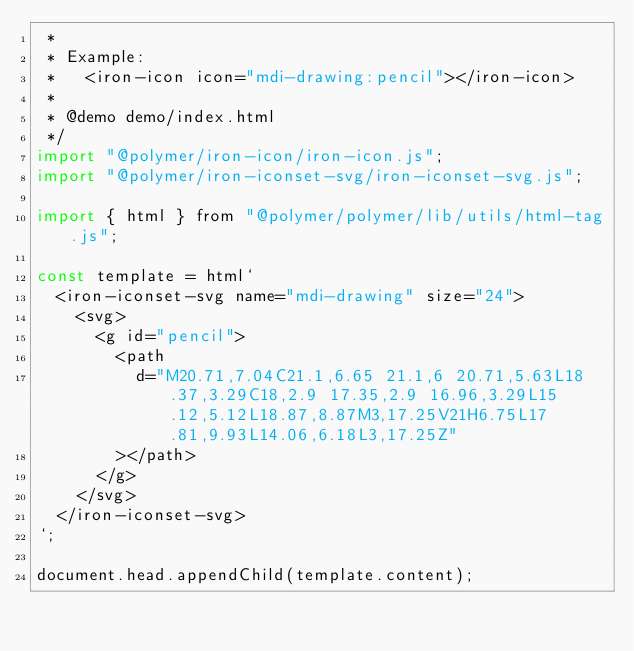Convert code to text. <code><loc_0><loc_0><loc_500><loc_500><_JavaScript_> *
 * Example:
 *   <iron-icon icon="mdi-drawing:pencil"></iron-icon>
 *
 * @demo demo/index.html
 */
import "@polymer/iron-icon/iron-icon.js";
import "@polymer/iron-iconset-svg/iron-iconset-svg.js";

import { html } from "@polymer/polymer/lib/utils/html-tag.js";

const template = html`
  <iron-iconset-svg name="mdi-drawing" size="24">
    <svg>
      <g id="pencil">
        <path
          d="M20.71,7.04C21.1,6.65 21.1,6 20.71,5.63L18.37,3.29C18,2.9 17.35,2.9 16.96,3.29L15.12,5.12L18.87,8.87M3,17.25V21H6.75L17.81,9.93L14.06,6.18L3,17.25Z"
        ></path>
      </g>
    </svg>
  </iron-iconset-svg>
`;

document.head.appendChild(template.content);
</code> 